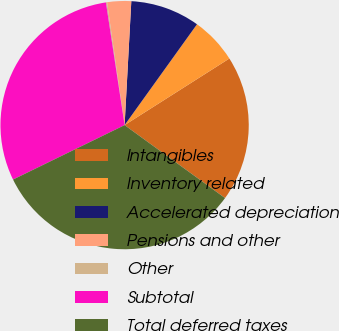<chart> <loc_0><loc_0><loc_500><loc_500><pie_chart><fcel>Intangibles<fcel>Inventory related<fcel>Accelerated depreciation<fcel>Pensions and other<fcel>Other<fcel>Subtotal<fcel>Total deferred taxes<nl><fcel>19.01%<fcel>6.08%<fcel>9.05%<fcel>3.12%<fcel>0.15%<fcel>29.82%<fcel>32.78%<nl></chart> 